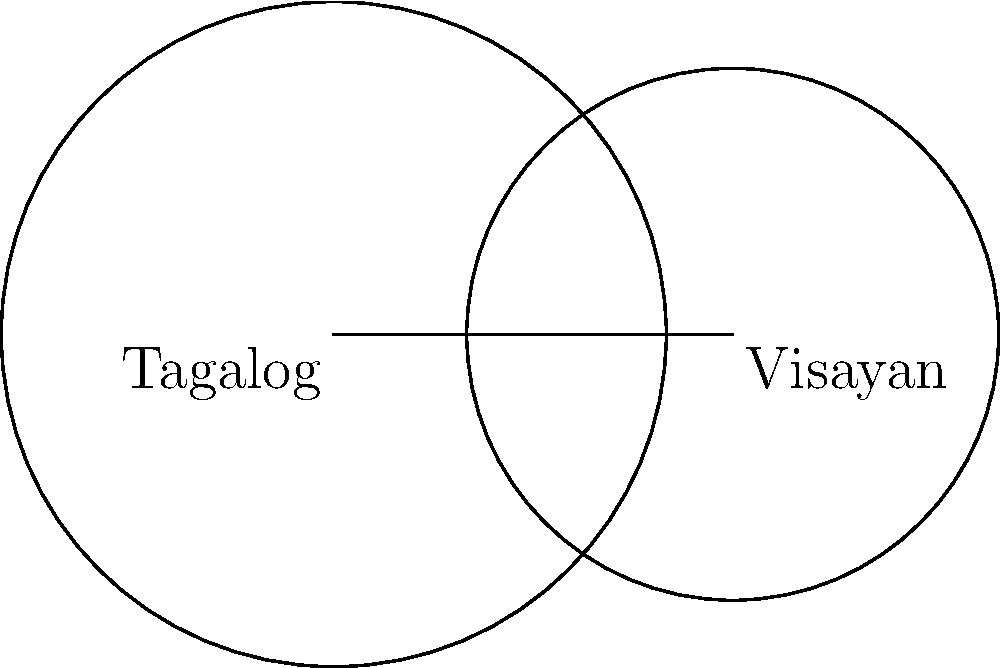Two overlapping cultural groups in the Philippines, Tagalog and Visayan, are represented by circles in a cultural diversity diagram. The Tagalog circle has a radius of 5 units, while the Visayan circle has a radius of 4 units. The centers of the circles are 6 units apart. Calculate the area of the region where these two cultures intersect, representing their shared cultural elements. Round your answer to two decimal places. Let's approach this step-by-step:

1) First, we need to find the distance from the center of each circle to the line of intersection. Let's call this distance $a$ for the Tagalog circle and $b$ for the Visayan circle.

2) We can use the Pythagorean theorem:

   $5^2 = a^2 + 3^2$ (for Tagalog circle)
   $4^2 = b^2 + 3^2$ (for Visayan circle)

3) Solving these equations:
   $a = \sqrt{5^2 - 3^2} = \sqrt{16} = 4$
   $b = \sqrt{4^2 - 3^2} = \sqrt{7} = 2.6458$

4) The area of intersection is the sum of two circular segments. The area of a circular segment is given by:

   $A = r^2 \arccos(\frac{d}{r}) - d\sqrt{r^2 - d^2}$

   where $r$ is the radius and $d$ is the distance from the center to the chord.

5) For the Tagalog circle:
   $A_1 = 5^2 \arccos(\frac{4}{5}) - 4\sqrt{5^2 - 4^2}$

6) For the Visayan circle:
   $A_2 = 4^2 \arccos(\frac{2.6458}{4}) - 2.6458\sqrt{4^2 - 2.6458^2}$

7) Total area of intersection:
   $A_{total} = A_1 + A_2$

8) Calculating this (using a calculator or computer):
   $A_{total} = 6.0351 + 6.0351 = 12.0702$

9) Rounding to two decimal places: 12.07
Answer: 12.07 square units 